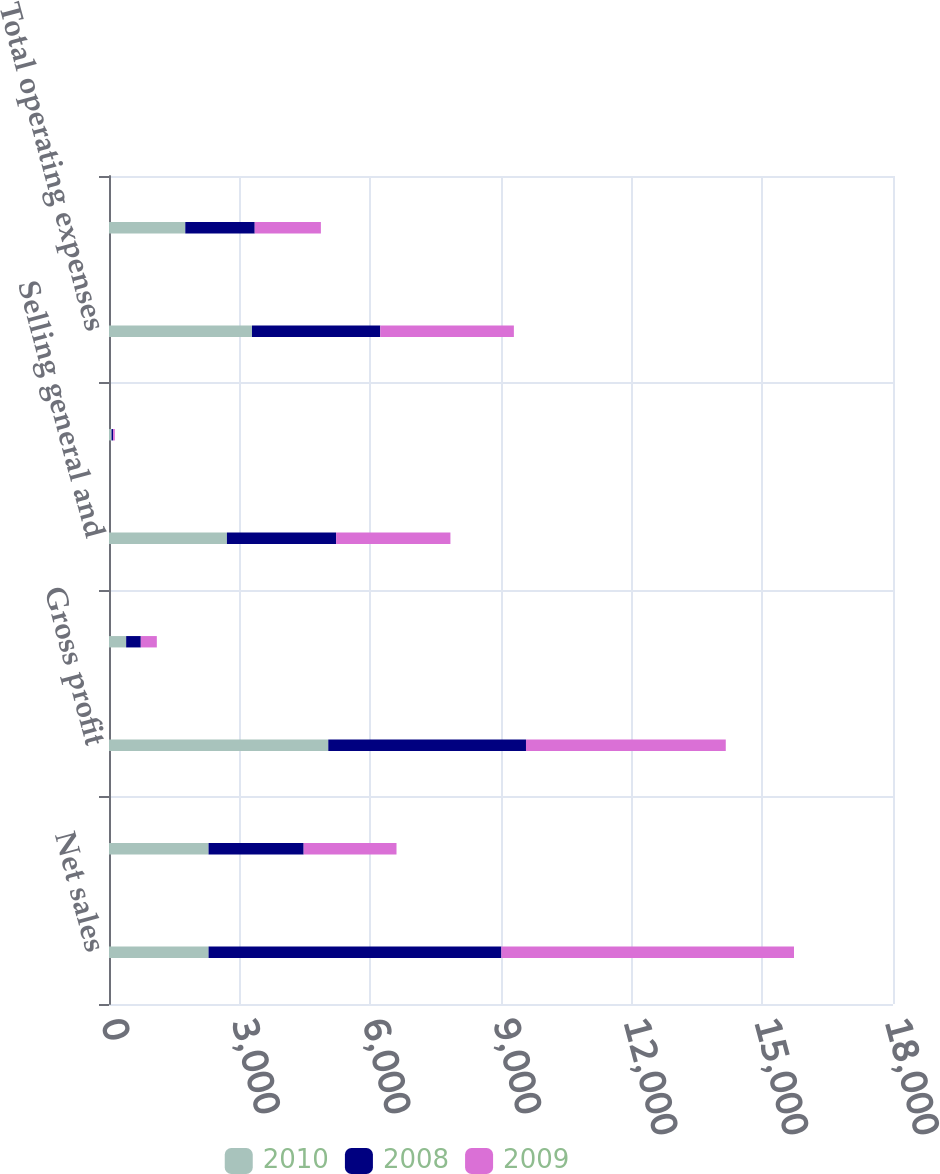Convert chart. <chart><loc_0><loc_0><loc_500><loc_500><stacked_bar_chart><ecel><fcel>Net sales<fcel>Cost of sales<fcel>Gross profit<fcel>Research development and<fcel>Selling general and<fcel>Intangible asset amortization<fcel>Total operating expenses<fcel>Operating income<nl><fcel>2010<fcel>2285.7<fcel>2285.7<fcel>5034.3<fcel>393.9<fcel>2707.3<fcel>58.2<fcel>3282.9<fcel>1751.4<nl><fcel>2008<fcel>6723.1<fcel>2183.7<fcel>4539.4<fcel>336.2<fcel>2506.3<fcel>35.5<fcel>2945<fcel>1594.4<nl><fcel>2009<fcel>6718.2<fcel>2131.4<fcel>4586.8<fcel>367.8<fcel>2625.1<fcel>40<fcel>3067.8<fcel>1519<nl></chart> 